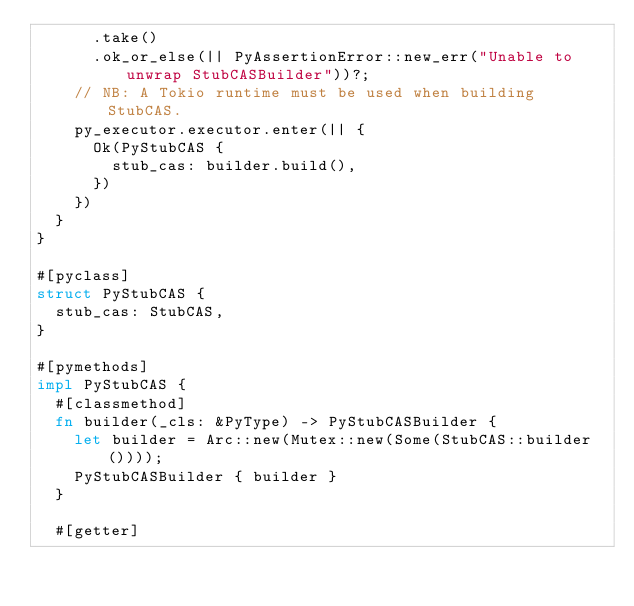<code> <loc_0><loc_0><loc_500><loc_500><_Rust_>      .take()
      .ok_or_else(|| PyAssertionError::new_err("Unable to unwrap StubCASBuilder"))?;
    // NB: A Tokio runtime must be used when building StubCAS.
    py_executor.executor.enter(|| {
      Ok(PyStubCAS {
        stub_cas: builder.build(),
      })
    })
  }
}

#[pyclass]
struct PyStubCAS {
  stub_cas: StubCAS,
}

#[pymethods]
impl PyStubCAS {
  #[classmethod]
  fn builder(_cls: &PyType) -> PyStubCASBuilder {
    let builder = Arc::new(Mutex::new(Some(StubCAS::builder())));
    PyStubCASBuilder { builder }
  }

  #[getter]</code> 